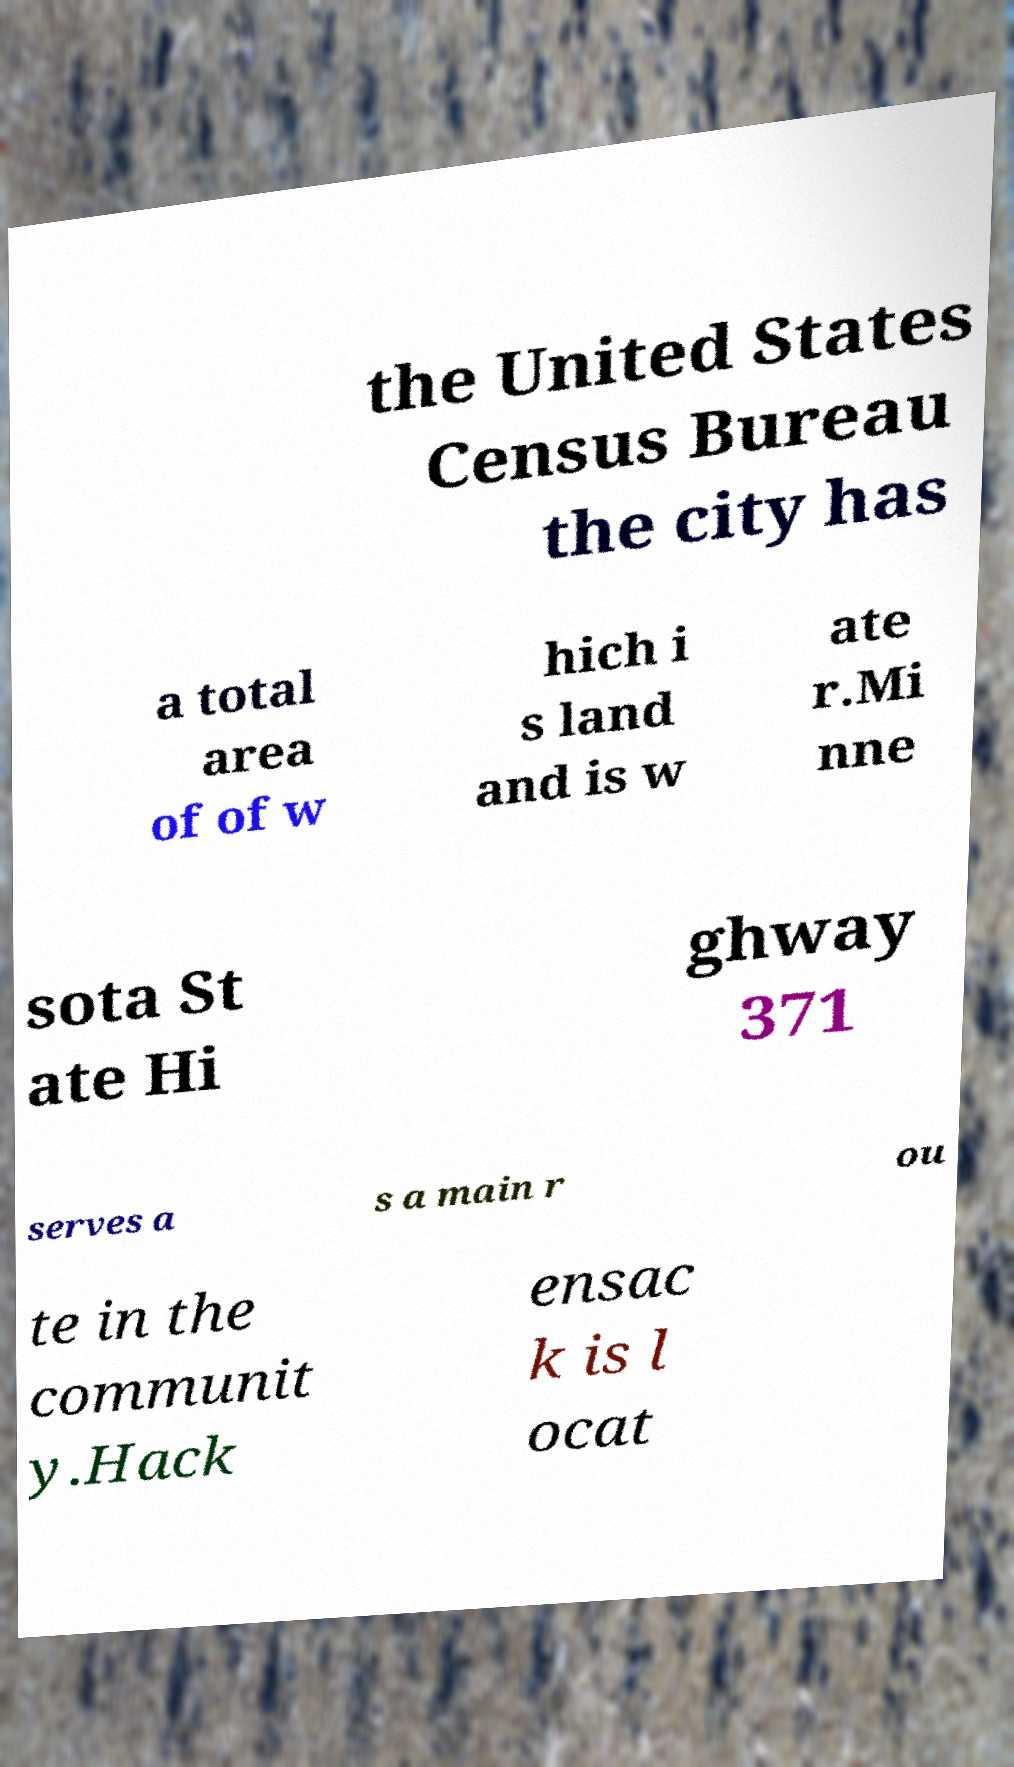Can you read and provide the text displayed in the image?This photo seems to have some interesting text. Can you extract and type it out for me? the United States Census Bureau the city has a total area of of w hich i s land and is w ate r.Mi nne sota St ate Hi ghway 371 serves a s a main r ou te in the communit y.Hack ensac k is l ocat 